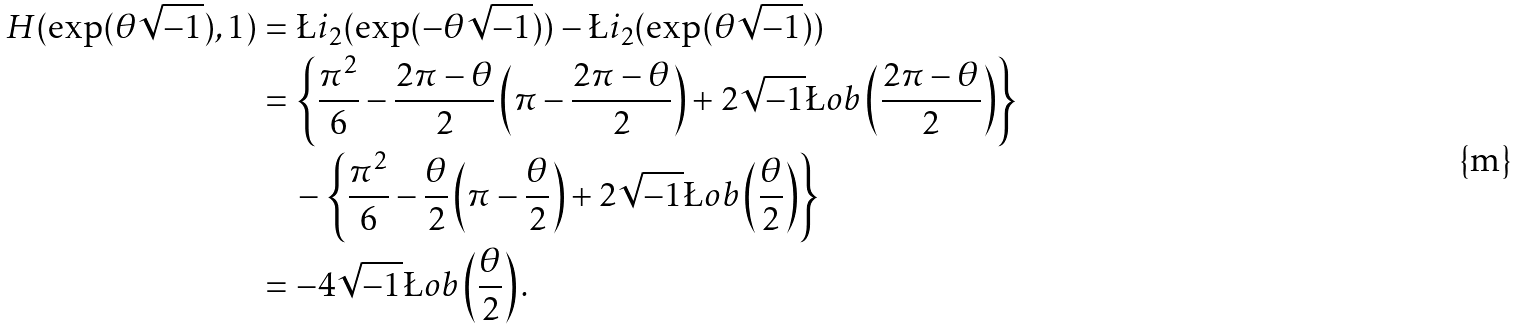<formula> <loc_0><loc_0><loc_500><loc_500>H ( \exp ( \theta \sqrt { - 1 } ) , 1 ) & = \L i _ { 2 } ( \exp ( - \theta \sqrt { - 1 } ) ) - \L i _ { 2 } ( \exp ( \theta \sqrt { - 1 } ) ) \\ & = \left \{ \frac { \pi ^ { 2 } } { 6 } - \frac { 2 \pi - \theta } { 2 } \left ( \pi - \frac { 2 \pi - \theta } { 2 } \right ) + 2 \sqrt { - 1 } \L o b \left ( \frac { 2 \pi - \theta } { 2 } \right ) \right \} \\ & \quad - \left \{ \frac { \pi ^ { 2 } } { 6 } - \frac { \theta } { 2 } \left ( \pi - \frac { \theta } { 2 } \right ) + 2 \sqrt { - 1 } \L o b \left ( \frac { \theta } { 2 } \right ) \right \} \\ & = - 4 \sqrt { - 1 } \L o b \left ( \frac { \theta } { 2 } \right ) .</formula> 